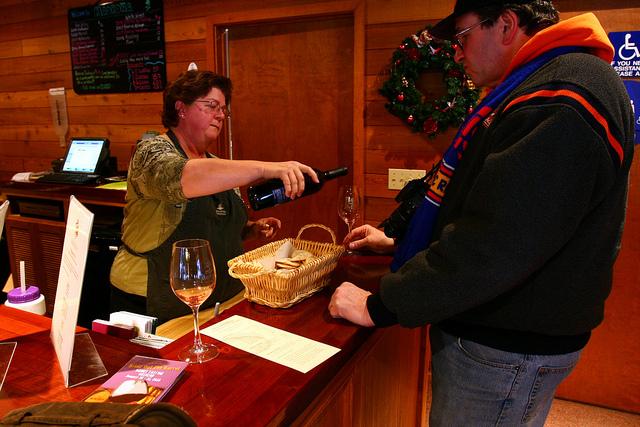What type of job does the women have?
Write a very short answer. Bartender. What does the blue sign indicate?
Answer briefly. Handicap. Is he thirsty?
Give a very brief answer. Yes. What is the woman pouring?
Short answer required. Wine. What season is depicted on the wall?
Write a very short answer. Christmas. How many people are there?
Keep it brief. 2. 